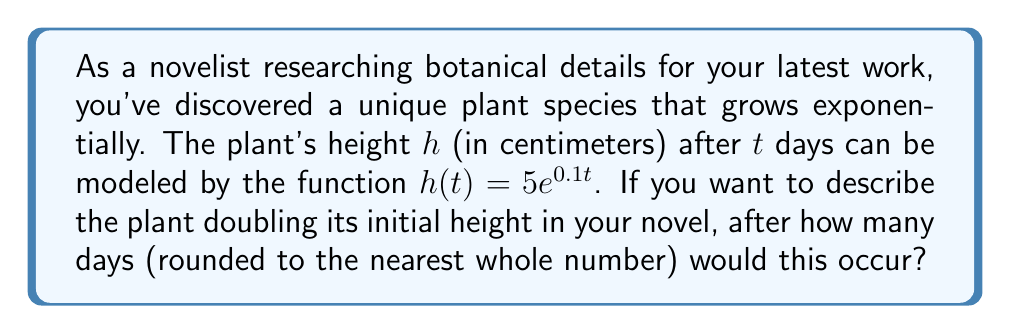Could you help me with this problem? Let's approach this step-by-step:

1) The initial height of the plant is when $t = 0$:
   $h(0) = 5e^{0.1(0)} = 5$ cm

2) We want to find when the height is double this initial height:
   $2h(0) = 2(5) = 10$ cm

3) So, we need to solve the equation:
   $5e^{0.1t} = 10$

4) Dividing both sides by 5:
   $e^{0.1t} = 2$

5) Taking the natural logarithm of both sides:
   $\ln(e^{0.1t}) = \ln(2)$
   $0.1t = \ln(2)$

6) Solving for $t$:
   $t = \frac{\ln(2)}{0.1}$

7) Using a calculator or computer:
   $t \approx 6.93147$

8) Rounding to the nearest whole number:
   $t \approx 7$ days

Therefore, in your novel, you could accurately describe the plant as doubling its height after 7 days.
Answer: 7 days 